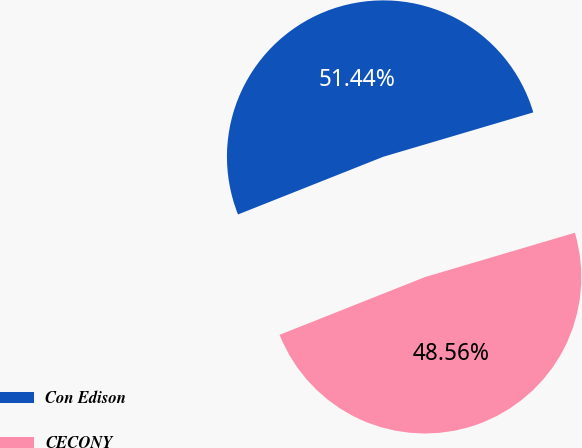Convert chart to OTSL. <chart><loc_0><loc_0><loc_500><loc_500><pie_chart><fcel>Con Edison<fcel>CECONY<nl><fcel>51.44%<fcel>48.56%<nl></chart> 